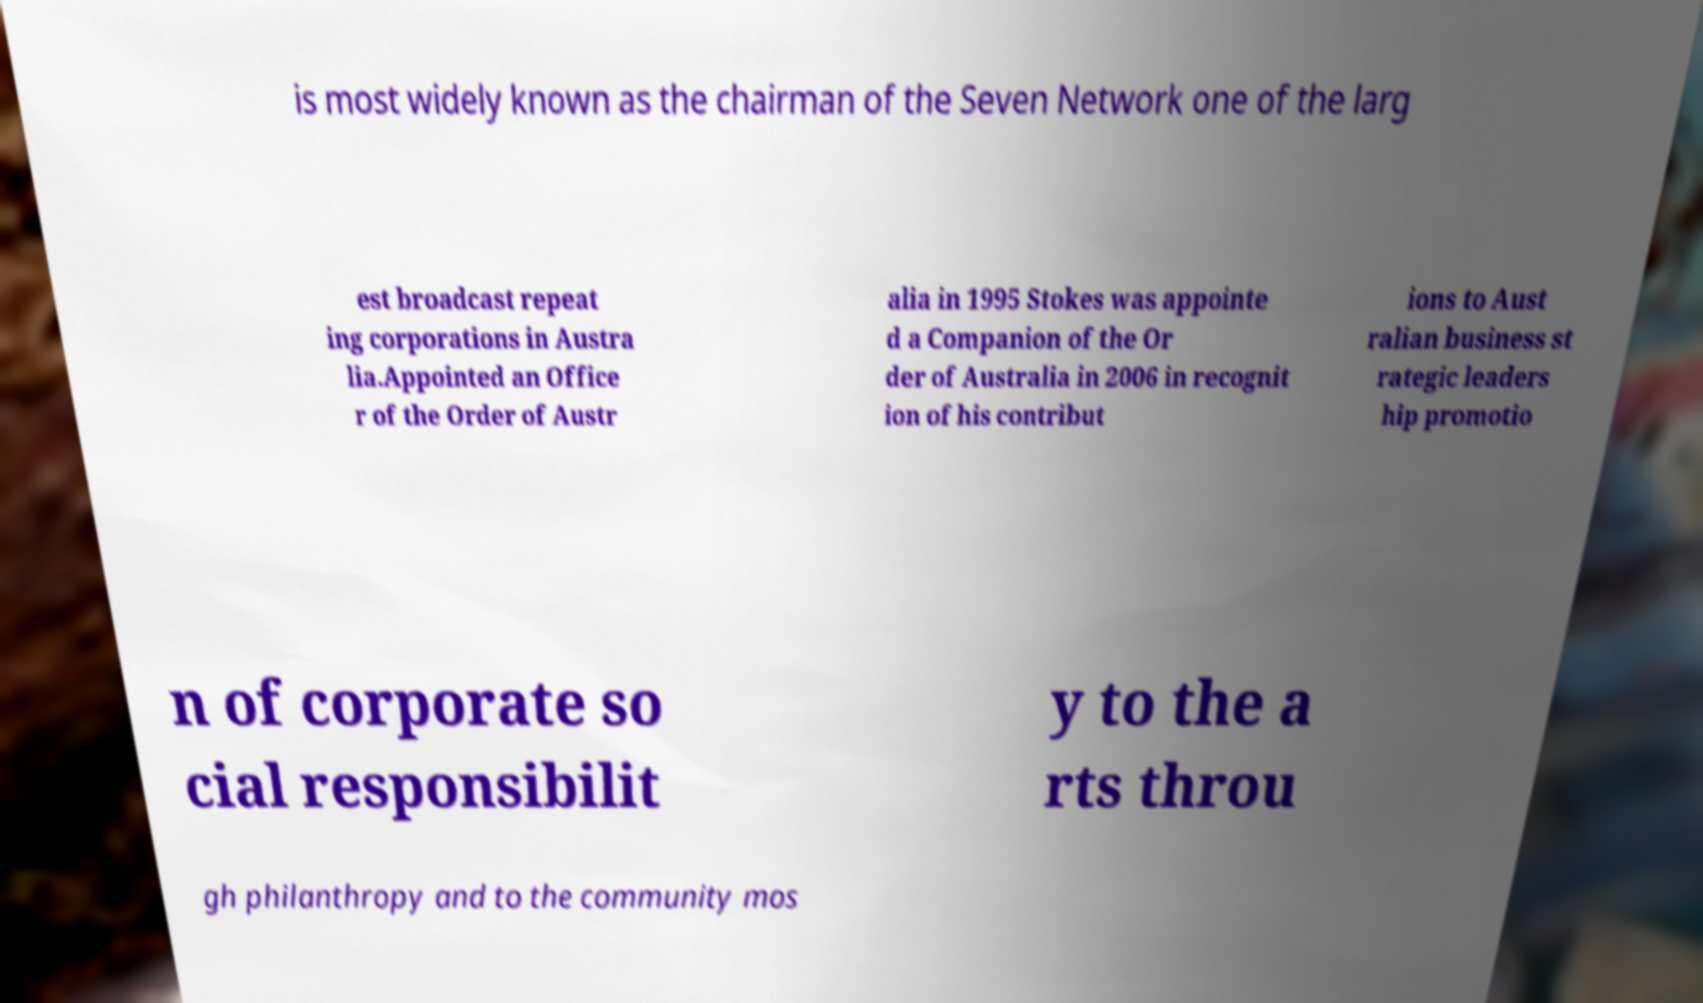I need the written content from this picture converted into text. Can you do that? is most widely known as the chairman of the Seven Network one of the larg est broadcast repeat ing corporations in Austra lia.Appointed an Office r of the Order of Austr alia in 1995 Stokes was appointe d a Companion of the Or der of Australia in 2006 in recognit ion of his contribut ions to Aust ralian business st rategic leaders hip promotio n of corporate so cial responsibilit y to the a rts throu gh philanthropy and to the community mos 